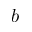Convert formula to latex. <formula><loc_0><loc_0><loc_500><loc_500>b</formula> 